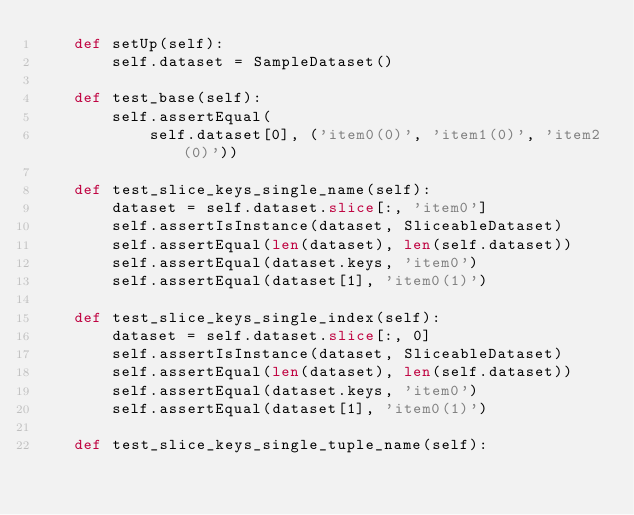Convert code to text. <code><loc_0><loc_0><loc_500><loc_500><_Python_>    def setUp(self):
        self.dataset = SampleDataset()

    def test_base(self):
        self.assertEqual(
            self.dataset[0], ('item0(0)', 'item1(0)', 'item2(0)'))

    def test_slice_keys_single_name(self):
        dataset = self.dataset.slice[:, 'item0']
        self.assertIsInstance(dataset, SliceableDataset)
        self.assertEqual(len(dataset), len(self.dataset))
        self.assertEqual(dataset.keys, 'item0')
        self.assertEqual(dataset[1], 'item0(1)')

    def test_slice_keys_single_index(self):
        dataset = self.dataset.slice[:, 0]
        self.assertIsInstance(dataset, SliceableDataset)
        self.assertEqual(len(dataset), len(self.dataset))
        self.assertEqual(dataset.keys, 'item0')
        self.assertEqual(dataset[1], 'item0(1)')

    def test_slice_keys_single_tuple_name(self):</code> 